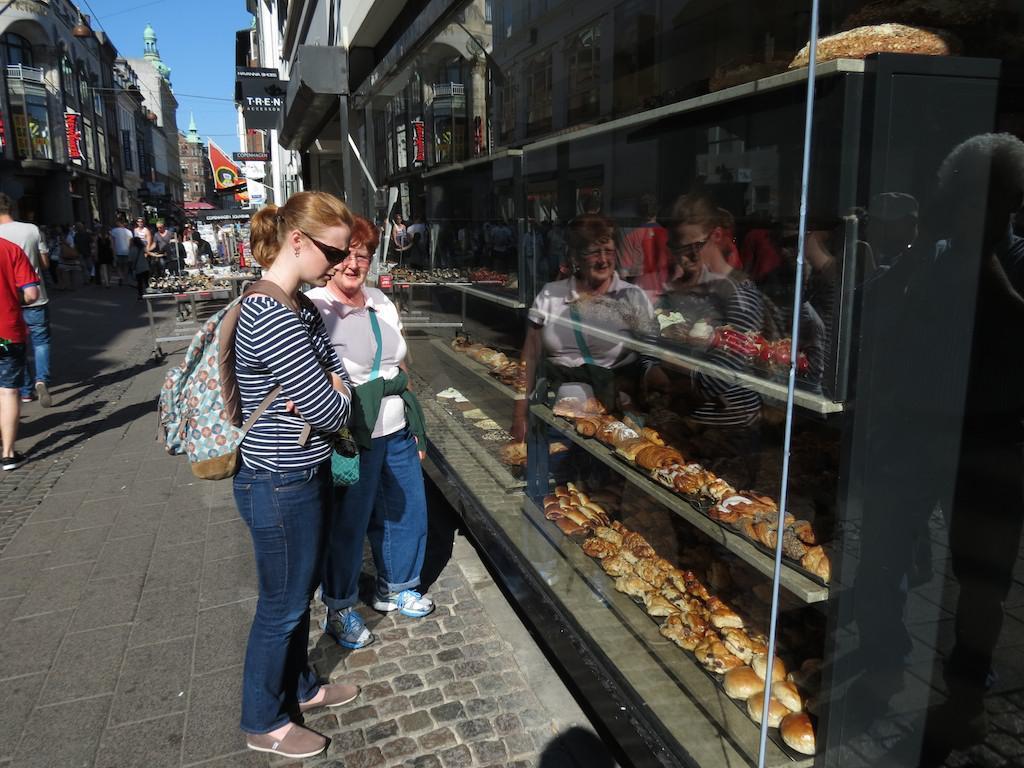In one or two sentences, can you explain what this image depicts? In this picture we can observe two women standing in front of the racks in which we can observe some food is placed. There are some people walking in this path. In the background there are buildings and a sky. 